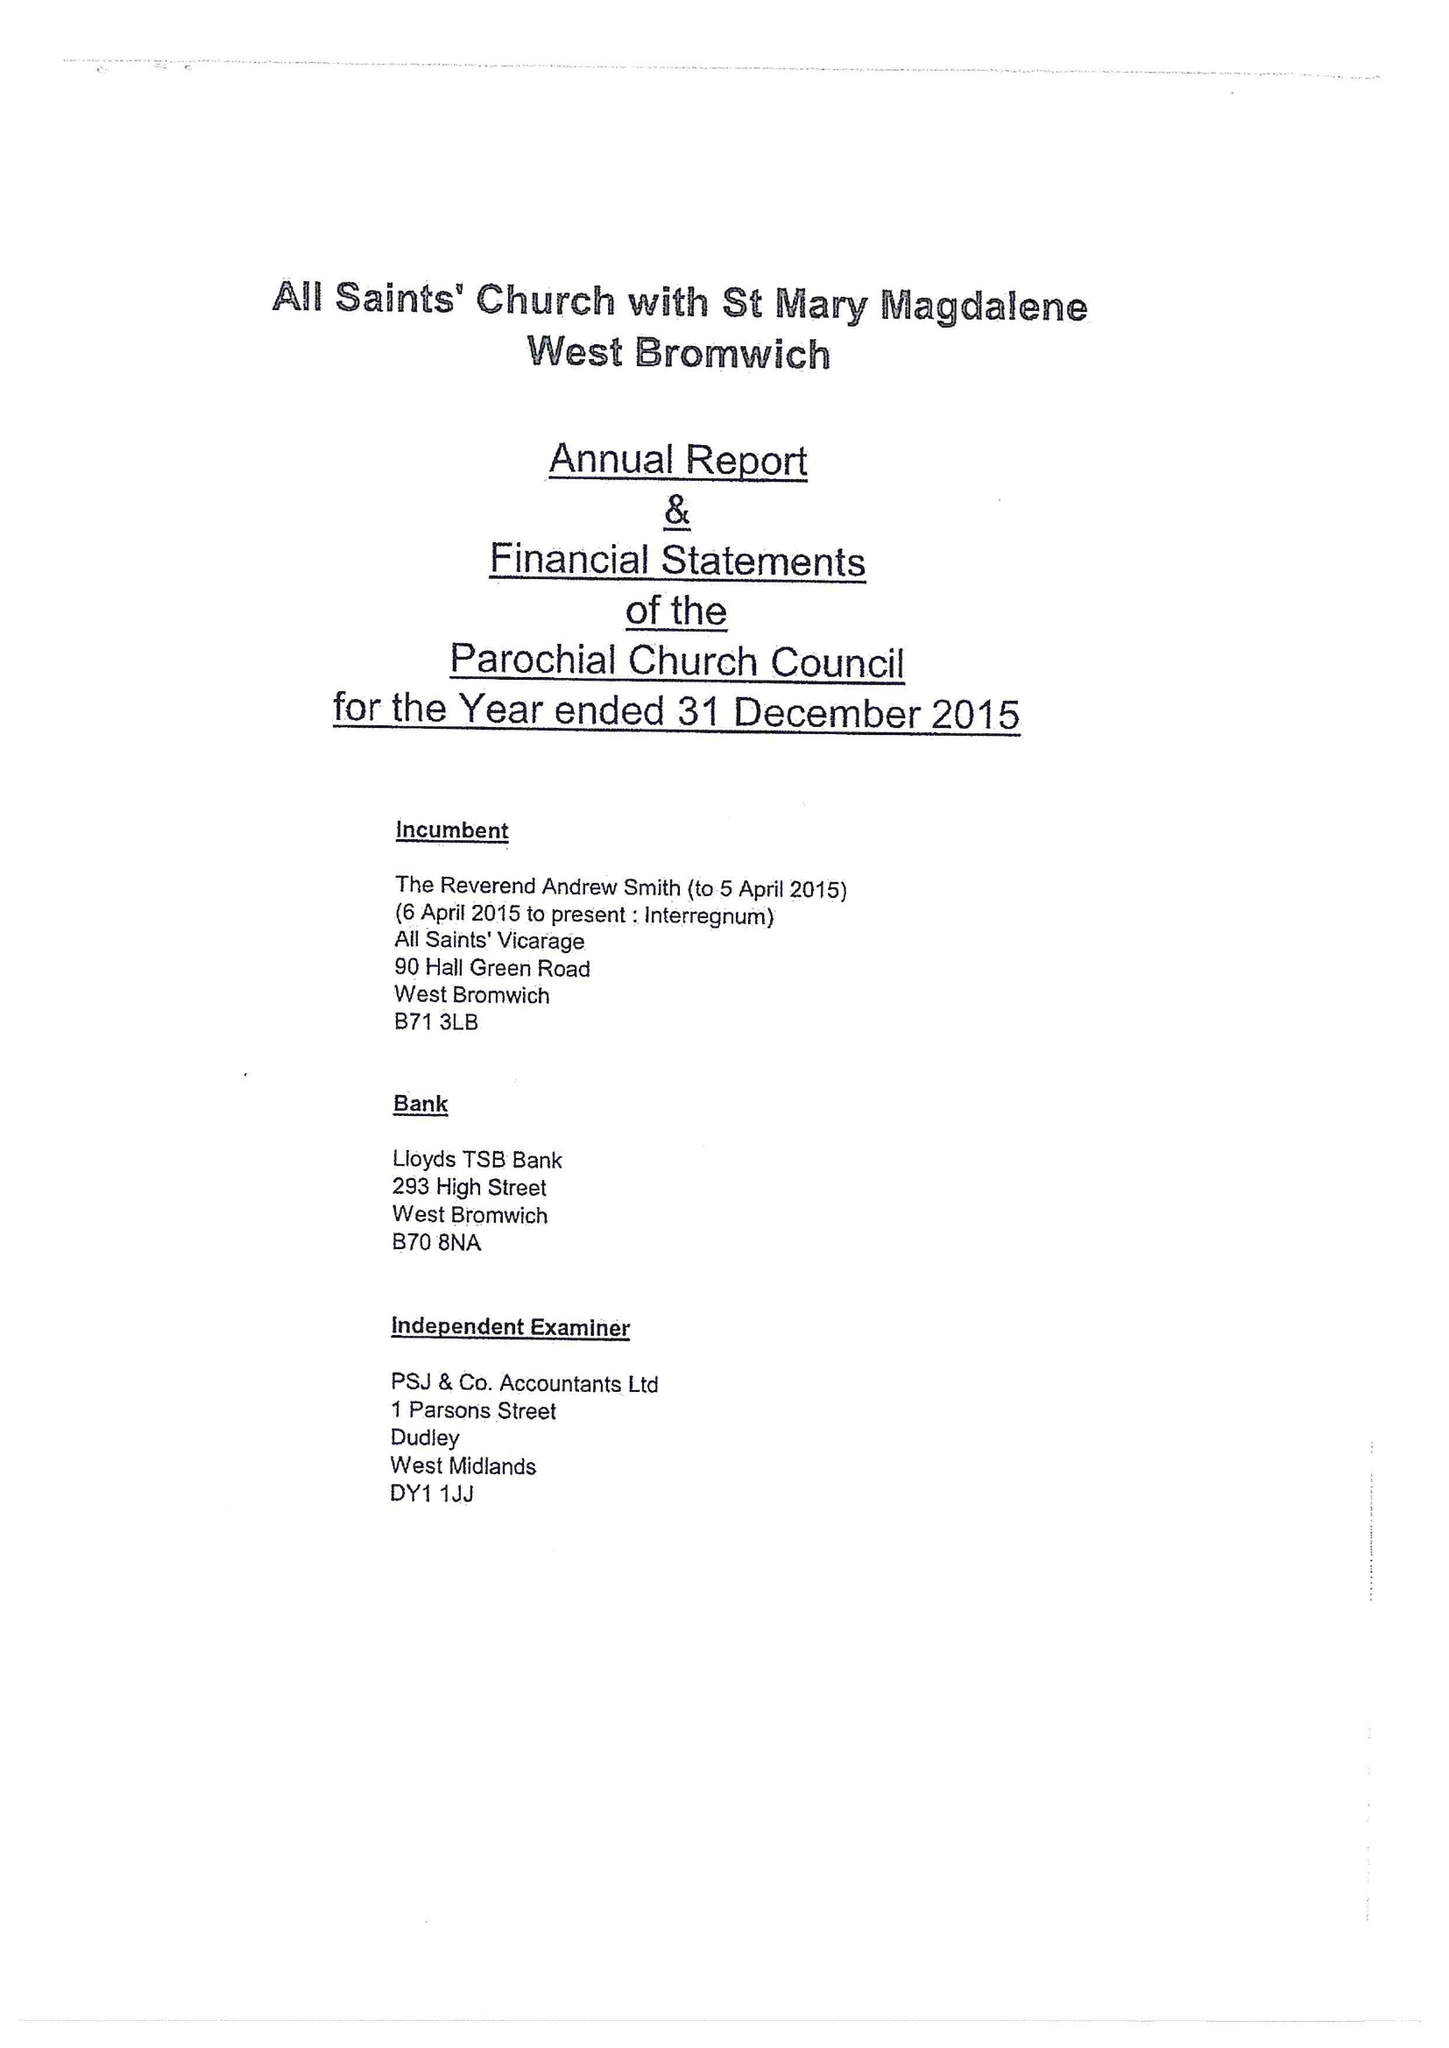What is the value for the charity_number?
Answer the question using a single word or phrase. 1153167 